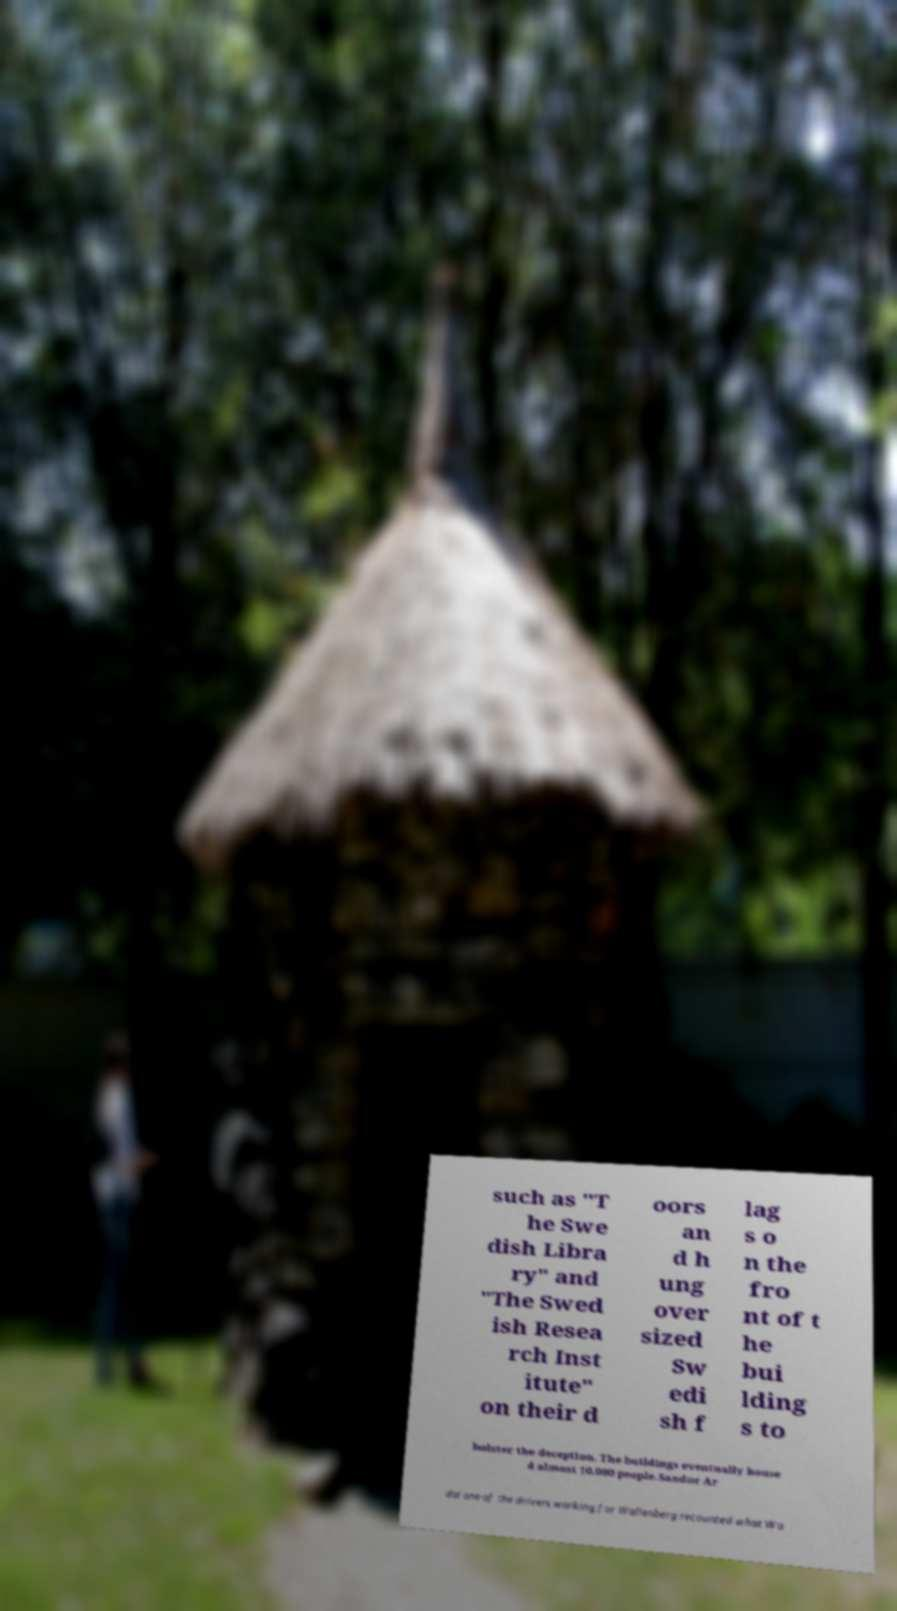Please read and relay the text visible in this image. What does it say? such as "T he Swe dish Libra ry" and "The Swed ish Resea rch Inst itute" on their d oors an d h ung over sized Sw edi sh f lag s o n the fro nt of t he bui lding s to bolster the deception. The buildings eventually house d almost 10,000 people.Sandor Ar dai one of the drivers working for Wallenberg recounted what Wa 